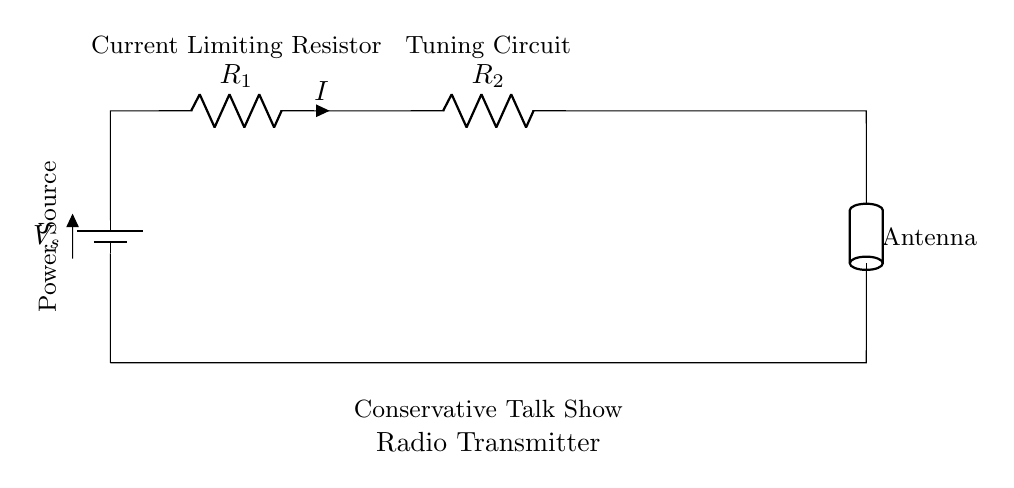What is the power source in this circuit? The power source is represented by a battery, labeled as V_s in the diagram.
Answer: battery What type of connectors are shown in this circuit? The connectors in this circuit are wires that connect the various components, allowing current to flow.
Answer: wires What is the total resistance in the circuit? The total resistance in a series circuit is the sum of individual resistances, which in this case would be R_1 plus R_2. This cannot be quantified without specific resistance values given for R_1 and R_2.
Answer: R_1 + R_2 What does the antenna do in this circuit? The antenna is designed to transmit the radio waves generated by the radio transmitter, allowing the conservative talk show signal to be broadcasted.
Answer: transmit radio waves What happens to the current when additional resistors are added in series? Adding more resistors in series increases the total resistance, which decreases the total current according to Ohm's Law (I = V/R). This shows how resistance impacts current flow.
Answer: decreases How do the components affect the performance of the transmitter? The performance of the transmitter is influenced primarily by the resistance values (which determine current flow) and the tuning circuit, which ensures that the correct frequency is transmitted. Higher resistance would lower current and potentially affect transmission range and quality.
Answer: affects transmission quality What is the role of the tuning circuit in this transmitter? The tuning circuit is essential for adjusting the frequency of the signal that the transmitter sends out, allowing it to operate on a specified radio frequency that listeners can tune into.
Answer: adjust frequency 